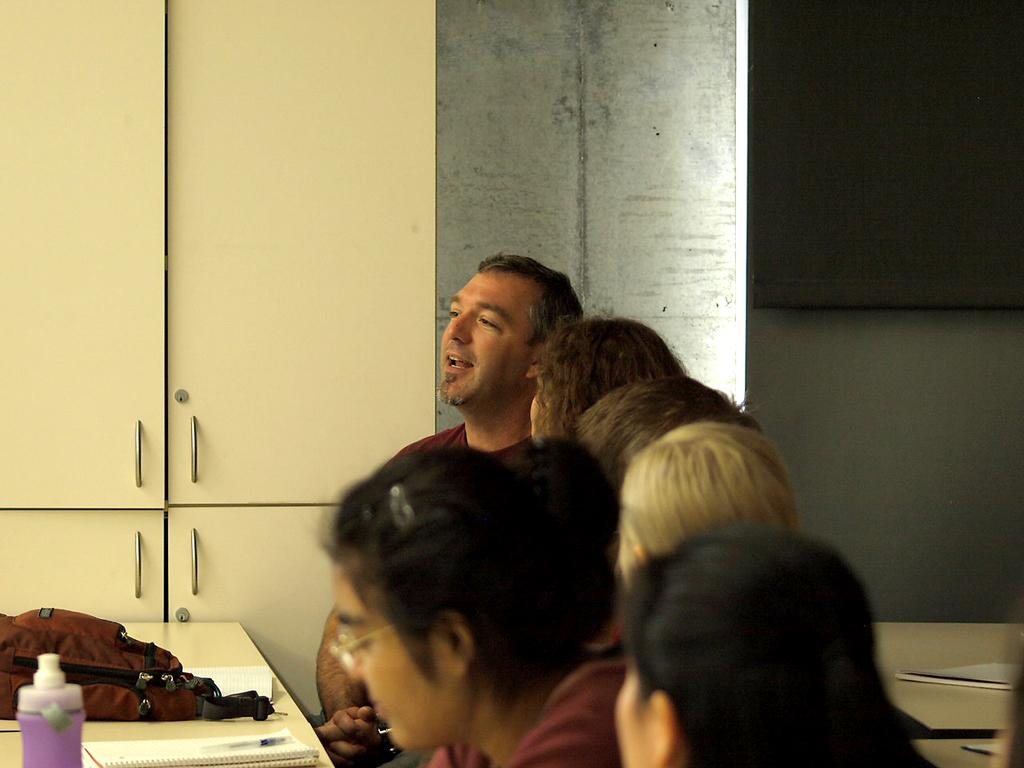Who or what is present in the image? There are people in the image. What objects can be seen on the table? There is a bag, a bottle, and a book on the table. What is visible in the background of the image? There is a cupboard in the background of the image. What type of key is used to open the door in the image? There is no door or key present in the image. How does the mom in the image interact with the people? There is no mom present in the image; only the people are visible. 